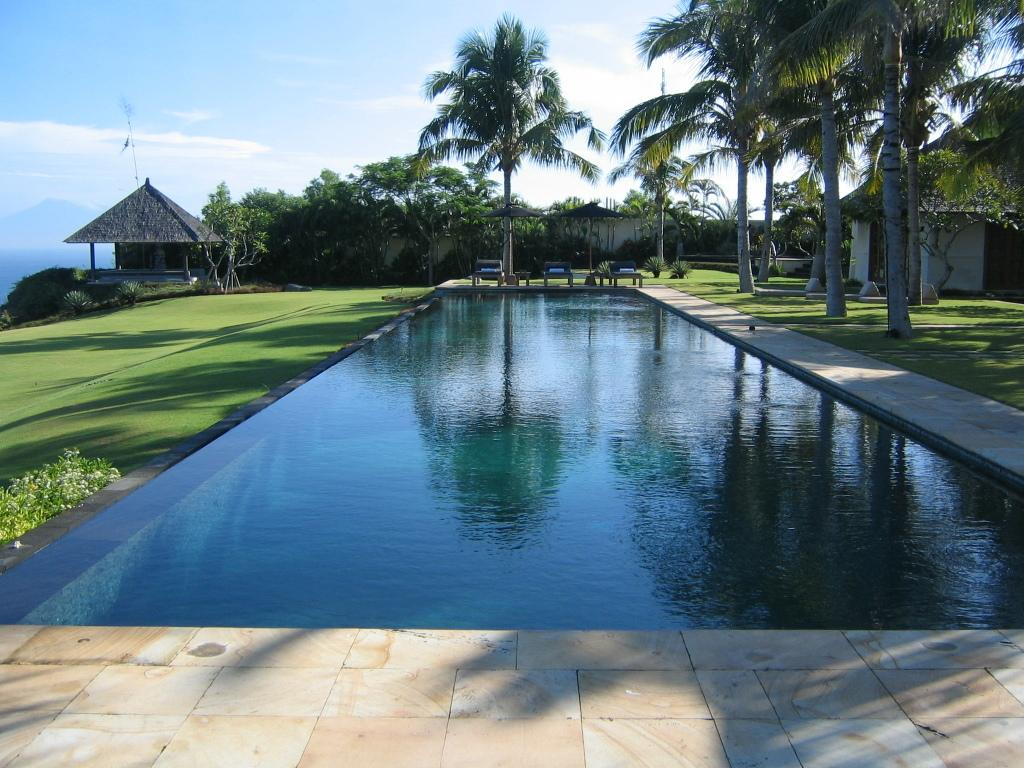What type of water feature is present in the image? There is a pool in the image. What type of seating can be seen in the image? There are benches in the image. What type of plant material is present in the image? There are seeds in the image. What type of vegetation is present in the image? There are trees in the image. What is visible in the background of the image? The sky is visible in the background of the image. Can you tell me how many people are exchanging seeds on the roof in the image? There is no exchange of seeds on a roof present in the image. What type of quicksand can be seen near the pool in the image? There is no quicksand present in the image. 